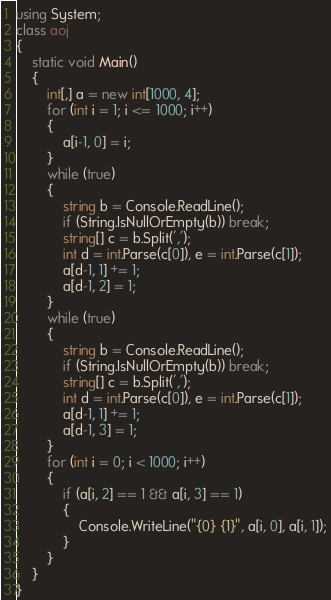Convert code to text. <code><loc_0><loc_0><loc_500><loc_500><_C#_>using System;
class aoj
{
    static void Main()
    {
        int[,] a = new int[1000, 4];
        for (int i = 1; i <= 1000; i++)
        {
            a[i-1, 0] = i;
        }
        while (true)
        {
            string b = Console.ReadLine();
            if (String.IsNullOrEmpty(b)) break;
            string[] c = b.Split(',');
            int d = int.Parse(c[0]), e = int.Parse(c[1]);
            a[d-1, 1] += 1;
            a[d-1, 2] = 1;
        }
        while (true)
        {
            string b = Console.ReadLine();
            if (String.IsNullOrEmpty(b)) break;
            string[] c = b.Split(',');
            int d = int.Parse(c[0]), e = int.Parse(c[1]);
            a[d-1, 1] += 1;
            a[d-1, 3] = 1;
        }
        for (int i = 0; i < 1000; i++)
        {
            if (a[i, 2] == 1 && a[i, 3] == 1)
            {
                Console.WriteLine("{0} {1}", a[i, 0], a[i, 1]);
            }
        }
    }
}</code> 